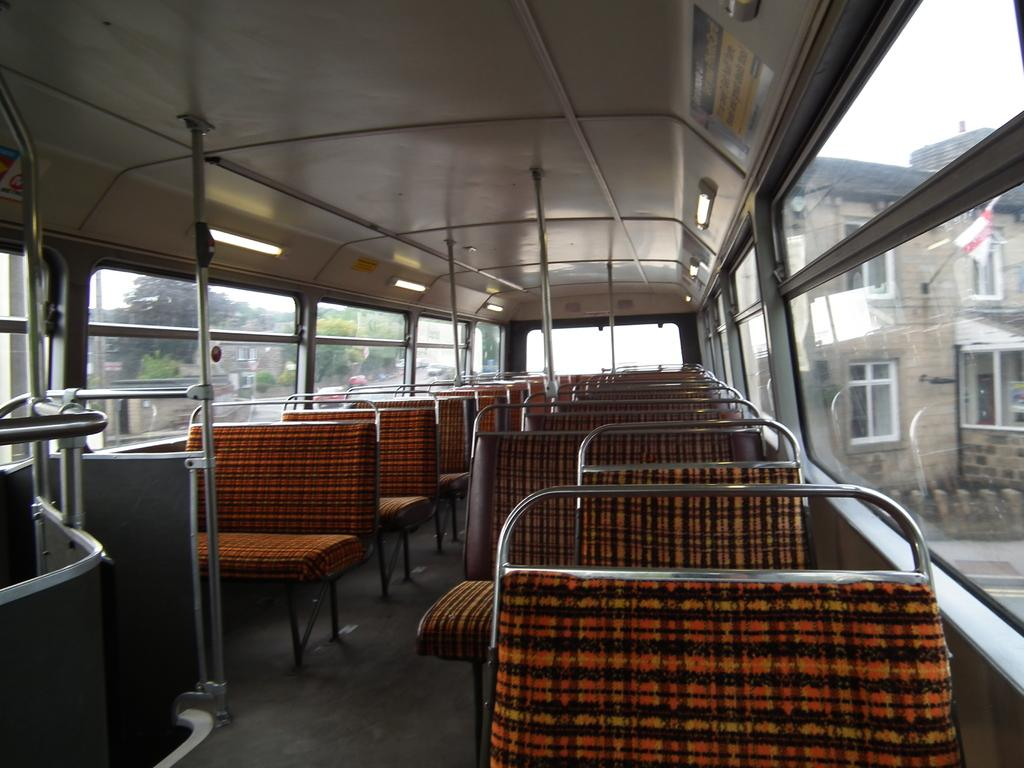What can be found inside the bus in the image? There are seats in the bus. What material are the rods in the bus made of? The rods in the bus are made of metal. What can be seen in the background of the image? There are trees and buildings in the background of the image. Where is the badge located on the bus in the image? There is no badge present on the bus in the image. What type of juice is being served to the passengers in the bus? There is: There is no juice or indication of passengers being served in the image. 